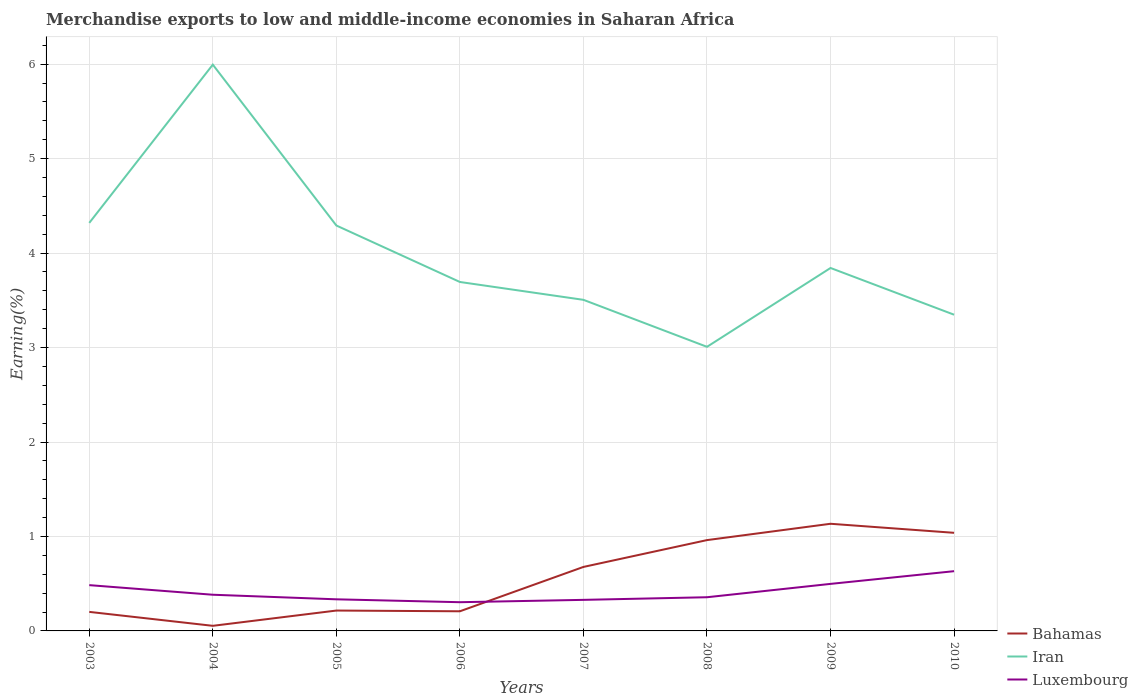How many different coloured lines are there?
Offer a terse response. 3. Does the line corresponding to Iran intersect with the line corresponding to Luxembourg?
Provide a short and direct response. No. Across all years, what is the maximum percentage of amount earned from merchandise exports in Luxembourg?
Make the answer very short. 0.3. What is the total percentage of amount earned from merchandise exports in Iran in the graph?
Your answer should be very brief. 0.5. What is the difference between the highest and the second highest percentage of amount earned from merchandise exports in Iran?
Offer a terse response. 2.99. What is the difference between the highest and the lowest percentage of amount earned from merchandise exports in Bahamas?
Your response must be concise. 4. How many years are there in the graph?
Your answer should be compact. 8. Are the values on the major ticks of Y-axis written in scientific E-notation?
Offer a terse response. No. Does the graph contain any zero values?
Offer a terse response. No. Where does the legend appear in the graph?
Offer a terse response. Bottom right. How many legend labels are there?
Ensure brevity in your answer.  3. What is the title of the graph?
Your answer should be very brief. Merchandise exports to low and middle-income economies in Saharan Africa. What is the label or title of the X-axis?
Your answer should be compact. Years. What is the label or title of the Y-axis?
Offer a terse response. Earning(%). What is the Earning(%) in Bahamas in 2003?
Offer a terse response. 0.2. What is the Earning(%) of Iran in 2003?
Provide a short and direct response. 4.32. What is the Earning(%) of Luxembourg in 2003?
Your response must be concise. 0.48. What is the Earning(%) of Bahamas in 2004?
Your response must be concise. 0.05. What is the Earning(%) in Iran in 2004?
Your answer should be very brief. 6. What is the Earning(%) of Luxembourg in 2004?
Your answer should be compact. 0.38. What is the Earning(%) of Bahamas in 2005?
Provide a short and direct response. 0.22. What is the Earning(%) in Iran in 2005?
Offer a very short reply. 4.29. What is the Earning(%) in Luxembourg in 2005?
Keep it short and to the point. 0.33. What is the Earning(%) of Bahamas in 2006?
Provide a short and direct response. 0.21. What is the Earning(%) of Iran in 2006?
Your answer should be very brief. 3.69. What is the Earning(%) of Luxembourg in 2006?
Keep it short and to the point. 0.3. What is the Earning(%) in Bahamas in 2007?
Your response must be concise. 0.68. What is the Earning(%) of Iran in 2007?
Offer a very short reply. 3.51. What is the Earning(%) in Luxembourg in 2007?
Offer a terse response. 0.33. What is the Earning(%) of Bahamas in 2008?
Offer a terse response. 0.96. What is the Earning(%) of Iran in 2008?
Your answer should be very brief. 3.01. What is the Earning(%) of Luxembourg in 2008?
Your answer should be compact. 0.36. What is the Earning(%) in Bahamas in 2009?
Keep it short and to the point. 1.13. What is the Earning(%) of Iran in 2009?
Your response must be concise. 3.84. What is the Earning(%) of Luxembourg in 2009?
Ensure brevity in your answer.  0.5. What is the Earning(%) of Bahamas in 2010?
Provide a short and direct response. 1.04. What is the Earning(%) of Iran in 2010?
Offer a very short reply. 3.35. What is the Earning(%) of Luxembourg in 2010?
Provide a succinct answer. 0.63. Across all years, what is the maximum Earning(%) of Bahamas?
Keep it short and to the point. 1.13. Across all years, what is the maximum Earning(%) in Iran?
Provide a succinct answer. 6. Across all years, what is the maximum Earning(%) in Luxembourg?
Offer a terse response. 0.63. Across all years, what is the minimum Earning(%) in Bahamas?
Offer a very short reply. 0.05. Across all years, what is the minimum Earning(%) in Iran?
Ensure brevity in your answer.  3.01. Across all years, what is the minimum Earning(%) in Luxembourg?
Offer a very short reply. 0.3. What is the total Earning(%) in Bahamas in the graph?
Your response must be concise. 4.49. What is the total Earning(%) in Iran in the graph?
Your response must be concise. 32. What is the total Earning(%) in Luxembourg in the graph?
Provide a short and direct response. 3.32. What is the difference between the Earning(%) in Bahamas in 2003 and that in 2004?
Your response must be concise. 0.15. What is the difference between the Earning(%) in Iran in 2003 and that in 2004?
Your answer should be very brief. -1.68. What is the difference between the Earning(%) in Luxembourg in 2003 and that in 2004?
Your answer should be compact. 0.1. What is the difference between the Earning(%) of Bahamas in 2003 and that in 2005?
Offer a very short reply. -0.01. What is the difference between the Earning(%) in Iran in 2003 and that in 2005?
Give a very brief answer. 0.03. What is the difference between the Earning(%) in Luxembourg in 2003 and that in 2005?
Ensure brevity in your answer.  0.15. What is the difference between the Earning(%) in Bahamas in 2003 and that in 2006?
Provide a short and direct response. -0.01. What is the difference between the Earning(%) in Iran in 2003 and that in 2006?
Offer a very short reply. 0.63. What is the difference between the Earning(%) of Luxembourg in 2003 and that in 2006?
Make the answer very short. 0.18. What is the difference between the Earning(%) of Bahamas in 2003 and that in 2007?
Offer a very short reply. -0.48. What is the difference between the Earning(%) in Iran in 2003 and that in 2007?
Make the answer very short. 0.81. What is the difference between the Earning(%) of Luxembourg in 2003 and that in 2007?
Ensure brevity in your answer.  0.16. What is the difference between the Earning(%) in Bahamas in 2003 and that in 2008?
Offer a terse response. -0.76. What is the difference between the Earning(%) in Iran in 2003 and that in 2008?
Keep it short and to the point. 1.31. What is the difference between the Earning(%) in Luxembourg in 2003 and that in 2008?
Keep it short and to the point. 0.13. What is the difference between the Earning(%) in Bahamas in 2003 and that in 2009?
Make the answer very short. -0.93. What is the difference between the Earning(%) of Iran in 2003 and that in 2009?
Provide a succinct answer. 0.48. What is the difference between the Earning(%) in Luxembourg in 2003 and that in 2009?
Offer a terse response. -0.01. What is the difference between the Earning(%) of Bahamas in 2003 and that in 2010?
Offer a terse response. -0.84. What is the difference between the Earning(%) of Iran in 2003 and that in 2010?
Give a very brief answer. 0.97. What is the difference between the Earning(%) in Luxembourg in 2003 and that in 2010?
Give a very brief answer. -0.15. What is the difference between the Earning(%) of Bahamas in 2004 and that in 2005?
Your answer should be very brief. -0.16. What is the difference between the Earning(%) in Iran in 2004 and that in 2005?
Offer a terse response. 1.7. What is the difference between the Earning(%) of Luxembourg in 2004 and that in 2005?
Provide a succinct answer. 0.05. What is the difference between the Earning(%) of Bahamas in 2004 and that in 2006?
Make the answer very short. -0.15. What is the difference between the Earning(%) in Iran in 2004 and that in 2006?
Ensure brevity in your answer.  2.3. What is the difference between the Earning(%) in Luxembourg in 2004 and that in 2006?
Keep it short and to the point. 0.08. What is the difference between the Earning(%) of Bahamas in 2004 and that in 2007?
Your response must be concise. -0.62. What is the difference between the Earning(%) in Iran in 2004 and that in 2007?
Provide a short and direct response. 2.49. What is the difference between the Earning(%) of Luxembourg in 2004 and that in 2007?
Your answer should be very brief. 0.05. What is the difference between the Earning(%) in Bahamas in 2004 and that in 2008?
Keep it short and to the point. -0.91. What is the difference between the Earning(%) in Iran in 2004 and that in 2008?
Offer a very short reply. 2.99. What is the difference between the Earning(%) of Luxembourg in 2004 and that in 2008?
Your answer should be compact. 0.03. What is the difference between the Earning(%) in Bahamas in 2004 and that in 2009?
Offer a terse response. -1.08. What is the difference between the Earning(%) in Iran in 2004 and that in 2009?
Your response must be concise. 2.15. What is the difference between the Earning(%) of Luxembourg in 2004 and that in 2009?
Give a very brief answer. -0.11. What is the difference between the Earning(%) in Bahamas in 2004 and that in 2010?
Keep it short and to the point. -0.98. What is the difference between the Earning(%) of Iran in 2004 and that in 2010?
Offer a terse response. 2.65. What is the difference between the Earning(%) of Luxembourg in 2004 and that in 2010?
Your response must be concise. -0.25. What is the difference between the Earning(%) in Bahamas in 2005 and that in 2006?
Ensure brevity in your answer.  0.01. What is the difference between the Earning(%) of Iran in 2005 and that in 2006?
Offer a terse response. 0.6. What is the difference between the Earning(%) in Luxembourg in 2005 and that in 2006?
Keep it short and to the point. 0.03. What is the difference between the Earning(%) of Bahamas in 2005 and that in 2007?
Make the answer very short. -0.46. What is the difference between the Earning(%) of Iran in 2005 and that in 2007?
Make the answer very short. 0.79. What is the difference between the Earning(%) in Luxembourg in 2005 and that in 2007?
Your answer should be compact. 0.01. What is the difference between the Earning(%) in Bahamas in 2005 and that in 2008?
Ensure brevity in your answer.  -0.75. What is the difference between the Earning(%) of Iran in 2005 and that in 2008?
Your response must be concise. 1.28. What is the difference between the Earning(%) of Luxembourg in 2005 and that in 2008?
Give a very brief answer. -0.02. What is the difference between the Earning(%) of Bahamas in 2005 and that in 2009?
Offer a terse response. -0.92. What is the difference between the Earning(%) in Iran in 2005 and that in 2009?
Offer a terse response. 0.45. What is the difference between the Earning(%) of Luxembourg in 2005 and that in 2009?
Offer a very short reply. -0.16. What is the difference between the Earning(%) of Bahamas in 2005 and that in 2010?
Your answer should be compact. -0.82. What is the difference between the Earning(%) in Iran in 2005 and that in 2010?
Offer a very short reply. 0.94. What is the difference between the Earning(%) of Luxembourg in 2005 and that in 2010?
Your answer should be compact. -0.3. What is the difference between the Earning(%) in Bahamas in 2006 and that in 2007?
Provide a short and direct response. -0.47. What is the difference between the Earning(%) in Iran in 2006 and that in 2007?
Provide a succinct answer. 0.19. What is the difference between the Earning(%) of Luxembourg in 2006 and that in 2007?
Your answer should be compact. -0.02. What is the difference between the Earning(%) in Bahamas in 2006 and that in 2008?
Keep it short and to the point. -0.75. What is the difference between the Earning(%) of Iran in 2006 and that in 2008?
Your response must be concise. 0.69. What is the difference between the Earning(%) in Luxembourg in 2006 and that in 2008?
Your response must be concise. -0.05. What is the difference between the Earning(%) in Bahamas in 2006 and that in 2009?
Ensure brevity in your answer.  -0.93. What is the difference between the Earning(%) in Iran in 2006 and that in 2009?
Provide a succinct answer. -0.15. What is the difference between the Earning(%) in Luxembourg in 2006 and that in 2009?
Provide a succinct answer. -0.19. What is the difference between the Earning(%) in Bahamas in 2006 and that in 2010?
Your answer should be very brief. -0.83. What is the difference between the Earning(%) in Iran in 2006 and that in 2010?
Offer a very short reply. 0.35. What is the difference between the Earning(%) in Luxembourg in 2006 and that in 2010?
Give a very brief answer. -0.33. What is the difference between the Earning(%) of Bahamas in 2007 and that in 2008?
Ensure brevity in your answer.  -0.28. What is the difference between the Earning(%) of Iran in 2007 and that in 2008?
Provide a short and direct response. 0.5. What is the difference between the Earning(%) of Luxembourg in 2007 and that in 2008?
Give a very brief answer. -0.03. What is the difference between the Earning(%) of Bahamas in 2007 and that in 2009?
Your answer should be very brief. -0.46. What is the difference between the Earning(%) of Iran in 2007 and that in 2009?
Provide a short and direct response. -0.34. What is the difference between the Earning(%) of Luxembourg in 2007 and that in 2009?
Your answer should be very brief. -0.17. What is the difference between the Earning(%) in Bahamas in 2007 and that in 2010?
Ensure brevity in your answer.  -0.36. What is the difference between the Earning(%) of Iran in 2007 and that in 2010?
Your answer should be compact. 0.16. What is the difference between the Earning(%) of Luxembourg in 2007 and that in 2010?
Make the answer very short. -0.3. What is the difference between the Earning(%) of Bahamas in 2008 and that in 2009?
Provide a succinct answer. -0.17. What is the difference between the Earning(%) of Iran in 2008 and that in 2009?
Give a very brief answer. -0.83. What is the difference between the Earning(%) of Luxembourg in 2008 and that in 2009?
Offer a terse response. -0.14. What is the difference between the Earning(%) in Bahamas in 2008 and that in 2010?
Give a very brief answer. -0.08. What is the difference between the Earning(%) in Iran in 2008 and that in 2010?
Offer a very short reply. -0.34. What is the difference between the Earning(%) of Luxembourg in 2008 and that in 2010?
Offer a terse response. -0.28. What is the difference between the Earning(%) of Bahamas in 2009 and that in 2010?
Give a very brief answer. 0.1. What is the difference between the Earning(%) in Iran in 2009 and that in 2010?
Offer a terse response. 0.49. What is the difference between the Earning(%) in Luxembourg in 2009 and that in 2010?
Offer a terse response. -0.13. What is the difference between the Earning(%) of Bahamas in 2003 and the Earning(%) of Iran in 2004?
Give a very brief answer. -5.79. What is the difference between the Earning(%) of Bahamas in 2003 and the Earning(%) of Luxembourg in 2004?
Offer a very short reply. -0.18. What is the difference between the Earning(%) in Iran in 2003 and the Earning(%) in Luxembourg in 2004?
Keep it short and to the point. 3.94. What is the difference between the Earning(%) in Bahamas in 2003 and the Earning(%) in Iran in 2005?
Your answer should be very brief. -4.09. What is the difference between the Earning(%) of Bahamas in 2003 and the Earning(%) of Luxembourg in 2005?
Your answer should be compact. -0.13. What is the difference between the Earning(%) in Iran in 2003 and the Earning(%) in Luxembourg in 2005?
Your answer should be very brief. 3.99. What is the difference between the Earning(%) in Bahamas in 2003 and the Earning(%) in Iran in 2006?
Ensure brevity in your answer.  -3.49. What is the difference between the Earning(%) in Bahamas in 2003 and the Earning(%) in Luxembourg in 2006?
Offer a terse response. -0.1. What is the difference between the Earning(%) in Iran in 2003 and the Earning(%) in Luxembourg in 2006?
Ensure brevity in your answer.  4.02. What is the difference between the Earning(%) of Bahamas in 2003 and the Earning(%) of Iran in 2007?
Your answer should be compact. -3.3. What is the difference between the Earning(%) in Bahamas in 2003 and the Earning(%) in Luxembourg in 2007?
Ensure brevity in your answer.  -0.13. What is the difference between the Earning(%) of Iran in 2003 and the Earning(%) of Luxembourg in 2007?
Keep it short and to the point. 3.99. What is the difference between the Earning(%) of Bahamas in 2003 and the Earning(%) of Iran in 2008?
Provide a succinct answer. -2.81. What is the difference between the Earning(%) in Bahamas in 2003 and the Earning(%) in Luxembourg in 2008?
Offer a terse response. -0.16. What is the difference between the Earning(%) in Iran in 2003 and the Earning(%) in Luxembourg in 2008?
Ensure brevity in your answer.  3.96. What is the difference between the Earning(%) of Bahamas in 2003 and the Earning(%) of Iran in 2009?
Provide a succinct answer. -3.64. What is the difference between the Earning(%) in Bahamas in 2003 and the Earning(%) in Luxembourg in 2009?
Your answer should be compact. -0.3. What is the difference between the Earning(%) of Iran in 2003 and the Earning(%) of Luxembourg in 2009?
Your response must be concise. 3.82. What is the difference between the Earning(%) of Bahamas in 2003 and the Earning(%) of Iran in 2010?
Keep it short and to the point. -3.15. What is the difference between the Earning(%) of Bahamas in 2003 and the Earning(%) of Luxembourg in 2010?
Provide a short and direct response. -0.43. What is the difference between the Earning(%) of Iran in 2003 and the Earning(%) of Luxembourg in 2010?
Keep it short and to the point. 3.69. What is the difference between the Earning(%) in Bahamas in 2004 and the Earning(%) in Iran in 2005?
Your answer should be very brief. -4.24. What is the difference between the Earning(%) in Bahamas in 2004 and the Earning(%) in Luxembourg in 2005?
Keep it short and to the point. -0.28. What is the difference between the Earning(%) of Iran in 2004 and the Earning(%) of Luxembourg in 2005?
Make the answer very short. 5.66. What is the difference between the Earning(%) in Bahamas in 2004 and the Earning(%) in Iran in 2006?
Your response must be concise. -3.64. What is the difference between the Earning(%) of Bahamas in 2004 and the Earning(%) of Luxembourg in 2006?
Offer a very short reply. -0.25. What is the difference between the Earning(%) of Iran in 2004 and the Earning(%) of Luxembourg in 2006?
Keep it short and to the point. 5.69. What is the difference between the Earning(%) of Bahamas in 2004 and the Earning(%) of Iran in 2007?
Keep it short and to the point. -3.45. What is the difference between the Earning(%) of Bahamas in 2004 and the Earning(%) of Luxembourg in 2007?
Make the answer very short. -0.27. What is the difference between the Earning(%) in Iran in 2004 and the Earning(%) in Luxembourg in 2007?
Offer a terse response. 5.67. What is the difference between the Earning(%) of Bahamas in 2004 and the Earning(%) of Iran in 2008?
Keep it short and to the point. -2.95. What is the difference between the Earning(%) of Bahamas in 2004 and the Earning(%) of Luxembourg in 2008?
Make the answer very short. -0.3. What is the difference between the Earning(%) of Iran in 2004 and the Earning(%) of Luxembourg in 2008?
Provide a short and direct response. 5.64. What is the difference between the Earning(%) in Bahamas in 2004 and the Earning(%) in Iran in 2009?
Make the answer very short. -3.79. What is the difference between the Earning(%) in Bahamas in 2004 and the Earning(%) in Luxembourg in 2009?
Ensure brevity in your answer.  -0.44. What is the difference between the Earning(%) of Iran in 2004 and the Earning(%) of Luxembourg in 2009?
Give a very brief answer. 5.5. What is the difference between the Earning(%) in Bahamas in 2004 and the Earning(%) in Iran in 2010?
Your answer should be compact. -3.29. What is the difference between the Earning(%) of Bahamas in 2004 and the Earning(%) of Luxembourg in 2010?
Your response must be concise. -0.58. What is the difference between the Earning(%) in Iran in 2004 and the Earning(%) in Luxembourg in 2010?
Offer a terse response. 5.36. What is the difference between the Earning(%) in Bahamas in 2005 and the Earning(%) in Iran in 2006?
Your answer should be very brief. -3.48. What is the difference between the Earning(%) in Bahamas in 2005 and the Earning(%) in Luxembourg in 2006?
Offer a terse response. -0.09. What is the difference between the Earning(%) of Iran in 2005 and the Earning(%) of Luxembourg in 2006?
Offer a very short reply. 3.99. What is the difference between the Earning(%) of Bahamas in 2005 and the Earning(%) of Iran in 2007?
Provide a short and direct response. -3.29. What is the difference between the Earning(%) of Bahamas in 2005 and the Earning(%) of Luxembourg in 2007?
Make the answer very short. -0.11. What is the difference between the Earning(%) of Iran in 2005 and the Earning(%) of Luxembourg in 2007?
Offer a terse response. 3.96. What is the difference between the Earning(%) of Bahamas in 2005 and the Earning(%) of Iran in 2008?
Keep it short and to the point. -2.79. What is the difference between the Earning(%) of Bahamas in 2005 and the Earning(%) of Luxembourg in 2008?
Make the answer very short. -0.14. What is the difference between the Earning(%) in Iran in 2005 and the Earning(%) in Luxembourg in 2008?
Your answer should be very brief. 3.94. What is the difference between the Earning(%) of Bahamas in 2005 and the Earning(%) of Iran in 2009?
Make the answer very short. -3.63. What is the difference between the Earning(%) in Bahamas in 2005 and the Earning(%) in Luxembourg in 2009?
Offer a terse response. -0.28. What is the difference between the Earning(%) in Iran in 2005 and the Earning(%) in Luxembourg in 2009?
Your response must be concise. 3.79. What is the difference between the Earning(%) in Bahamas in 2005 and the Earning(%) in Iran in 2010?
Provide a succinct answer. -3.13. What is the difference between the Earning(%) in Bahamas in 2005 and the Earning(%) in Luxembourg in 2010?
Make the answer very short. -0.42. What is the difference between the Earning(%) of Iran in 2005 and the Earning(%) of Luxembourg in 2010?
Ensure brevity in your answer.  3.66. What is the difference between the Earning(%) in Bahamas in 2006 and the Earning(%) in Iran in 2007?
Your response must be concise. -3.3. What is the difference between the Earning(%) of Bahamas in 2006 and the Earning(%) of Luxembourg in 2007?
Your response must be concise. -0.12. What is the difference between the Earning(%) in Iran in 2006 and the Earning(%) in Luxembourg in 2007?
Provide a short and direct response. 3.37. What is the difference between the Earning(%) in Bahamas in 2006 and the Earning(%) in Iran in 2008?
Ensure brevity in your answer.  -2.8. What is the difference between the Earning(%) in Bahamas in 2006 and the Earning(%) in Luxembourg in 2008?
Ensure brevity in your answer.  -0.15. What is the difference between the Earning(%) in Iran in 2006 and the Earning(%) in Luxembourg in 2008?
Ensure brevity in your answer.  3.34. What is the difference between the Earning(%) of Bahamas in 2006 and the Earning(%) of Iran in 2009?
Offer a terse response. -3.63. What is the difference between the Earning(%) of Bahamas in 2006 and the Earning(%) of Luxembourg in 2009?
Make the answer very short. -0.29. What is the difference between the Earning(%) of Iran in 2006 and the Earning(%) of Luxembourg in 2009?
Your answer should be very brief. 3.2. What is the difference between the Earning(%) of Bahamas in 2006 and the Earning(%) of Iran in 2010?
Offer a very short reply. -3.14. What is the difference between the Earning(%) in Bahamas in 2006 and the Earning(%) in Luxembourg in 2010?
Keep it short and to the point. -0.42. What is the difference between the Earning(%) of Iran in 2006 and the Earning(%) of Luxembourg in 2010?
Keep it short and to the point. 3.06. What is the difference between the Earning(%) in Bahamas in 2007 and the Earning(%) in Iran in 2008?
Give a very brief answer. -2.33. What is the difference between the Earning(%) in Bahamas in 2007 and the Earning(%) in Luxembourg in 2008?
Provide a succinct answer. 0.32. What is the difference between the Earning(%) in Iran in 2007 and the Earning(%) in Luxembourg in 2008?
Provide a succinct answer. 3.15. What is the difference between the Earning(%) of Bahamas in 2007 and the Earning(%) of Iran in 2009?
Your answer should be compact. -3.16. What is the difference between the Earning(%) in Bahamas in 2007 and the Earning(%) in Luxembourg in 2009?
Offer a very short reply. 0.18. What is the difference between the Earning(%) of Iran in 2007 and the Earning(%) of Luxembourg in 2009?
Offer a very short reply. 3.01. What is the difference between the Earning(%) of Bahamas in 2007 and the Earning(%) of Iran in 2010?
Your response must be concise. -2.67. What is the difference between the Earning(%) in Bahamas in 2007 and the Earning(%) in Luxembourg in 2010?
Make the answer very short. 0.05. What is the difference between the Earning(%) of Iran in 2007 and the Earning(%) of Luxembourg in 2010?
Your response must be concise. 2.87. What is the difference between the Earning(%) of Bahamas in 2008 and the Earning(%) of Iran in 2009?
Your answer should be compact. -2.88. What is the difference between the Earning(%) in Bahamas in 2008 and the Earning(%) in Luxembourg in 2009?
Your answer should be compact. 0.46. What is the difference between the Earning(%) of Iran in 2008 and the Earning(%) of Luxembourg in 2009?
Your answer should be very brief. 2.51. What is the difference between the Earning(%) in Bahamas in 2008 and the Earning(%) in Iran in 2010?
Make the answer very short. -2.39. What is the difference between the Earning(%) in Bahamas in 2008 and the Earning(%) in Luxembourg in 2010?
Make the answer very short. 0.33. What is the difference between the Earning(%) in Iran in 2008 and the Earning(%) in Luxembourg in 2010?
Give a very brief answer. 2.38. What is the difference between the Earning(%) in Bahamas in 2009 and the Earning(%) in Iran in 2010?
Give a very brief answer. -2.21. What is the difference between the Earning(%) of Bahamas in 2009 and the Earning(%) of Luxembourg in 2010?
Your response must be concise. 0.5. What is the difference between the Earning(%) of Iran in 2009 and the Earning(%) of Luxembourg in 2010?
Your response must be concise. 3.21. What is the average Earning(%) in Bahamas per year?
Offer a very short reply. 0.56. What is the average Earning(%) in Iran per year?
Give a very brief answer. 4. What is the average Earning(%) of Luxembourg per year?
Your response must be concise. 0.42. In the year 2003, what is the difference between the Earning(%) in Bahamas and Earning(%) in Iran?
Ensure brevity in your answer.  -4.12. In the year 2003, what is the difference between the Earning(%) of Bahamas and Earning(%) of Luxembourg?
Offer a terse response. -0.28. In the year 2003, what is the difference between the Earning(%) of Iran and Earning(%) of Luxembourg?
Keep it short and to the point. 3.84. In the year 2004, what is the difference between the Earning(%) of Bahamas and Earning(%) of Iran?
Make the answer very short. -5.94. In the year 2004, what is the difference between the Earning(%) in Bahamas and Earning(%) in Luxembourg?
Your answer should be very brief. -0.33. In the year 2004, what is the difference between the Earning(%) of Iran and Earning(%) of Luxembourg?
Your answer should be very brief. 5.61. In the year 2005, what is the difference between the Earning(%) of Bahamas and Earning(%) of Iran?
Your response must be concise. -4.08. In the year 2005, what is the difference between the Earning(%) of Bahamas and Earning(%) of Luxembourg?
Offer a terse response. -0.12. In the year 2005, what is the difference between the Earning(%) in Iran and Earning(%) in Luxembourg?
Make the answer very short. 3.96. In the year 2006, what is the difference between the Earning(%) in Bahamas and Earning(%) in Iran?
Make the answer very short. -3.49. In the year 2006, what is the difference between the Earning(%) of Bahamas and Earning(%) of Luxembourg?
Your answer should be very brief. -0.1. In the year 2006, what is the difference between the Earning(%) of Iran and Earning(%) of Luxembourg?
Make the answer very short. 3.39. In the year 2007, what is the difference between the Earning(%) of Bahamas and Earning(%) of Iran?
Keep it short and to the point. -2.83. In the year 2007, what is the difference between the Earning(%) in Bahamas and Earning(%) in Luxembourg?
Your answer should be compact. 0.35. In the year 2007, what is the difference between the Earning(%) in Iran and Earning(%) in Luxembourg?
Offer a very short reply. 3.18. In the year 2008, what is the difference between the Earning(%) of Bahamas and Earning(%) of Iran?
Give a very brief answer. -2.05. In the year 2008, what is the difference between the Earning(%) of Bahamas and Earning(%) of Luxembourg?
Your response must be concise. 0.6. In the year 2008, what is the difference between the Earning(%) in Iran and Earning(%) in Luxembourg?
Your answer should be compact. 2.65. In the year 2009, what is the difference between the Earning(%) in Bahamas and Earning(%) in Iran?
Offer a very short reply. -2.71. In the year 2009, what is the difference between the Earning(%) of Bahamas and Earning(%) of Luxembourg?
Give a very brief answer. 0.64. In the year 2009, what is the difference between the Earning(%) in Iran and Earning(%) in Luxembourg?
Provide a succinct answer. 3.34. In the year 2010, what is the difference between the Earning(%) in Bahamas and Earning(%) in Iran?
Your answer should be compact. -2.31. In the year 2010, what is the difference between the Earning(%) of Bahamas and Earning(%) of Luxembourg?
Keep it short and to the point. 0.41. In the year 2010, what is the difference between the Earning(%) in Iran and Earning(%) in Luxembourg?
Your response must be concise. 2.72. What is the ratio of the Earning(%) of Bahamas in 2003 to that in 2004?
Your answer should be compact. 3.73. What is the ratio of the Earning(%) in Iran in 2003 to that in 2004?
Your answer should be very brief. 0.72. What is the ratio of the Earning(%) of Luxembourg in 2003 to that in 2004?
Give a very brief answer. 1.27. What is the ratio of the Earning(%) of Bahamas in 2003 to that in 2005?
Keep it short and to the point. 0.93. What is the ratio of the Earning(%) in Iran in 2003 to that in 2005?
Offer a very short reply. 1.01. What is the ratio of the Earning(%) of Luxembourg in 2003 to that in 2005?
Your answer should be very brief. 1.45. What is the ratio of the Earning(%) in Bahamas in 2003 to that in 2006?
Your answer should be compact. 0.97. What is the ratio of the Earning(%) of Iran in 2003 to that in 2006?
Offer a terse response. 1.17. What is the ratio of the Earning(%) in Luxembourg in 2003 to that in 2006?
Offer a very short reply. 1.59. What is the ratio of the Earning(%) in Bahamas in 2003 to that in 2007?
Your answer should be compact. 0.3. What is the ratio of the Earning(%) in Iran in 2003 to that in 2007?
Offer a terse response. 1.23. What is the ratio of the Earning(%) in Luxembourg in 2003 to that in 2007?
Ensure brevity in your answer.  1.47. What is the ratio of the Earning(%) of Bahamas in 2003 to that in 2008?
Offer a very short reply. 0.21. What is the ratio of the Earning(%) in Iran in 2003 to that in 2008?
Offer a very short reply. 1.44. What is the ratio of the Earning(%) in Luxembourg in 2003 to that in 2008?
Provide a succinct answer. 1.36. What is the ratio of the Earning(%) of Bahamas in 2003 to that in 2009?
Make the answer very short. 0.18. What is the ratio of the Earning(%) of Iran in 2003 to that in 2009?
Offer a very short reply. 1.12. What is the ratio of the Earning(%) of Luxembourg in 2003 to that in 2009?
Offer a very short reply. 0.97. What is the ratio of the Earning(%) of Bahamas in 2003 to that in 2010?
Your response must be concise. 0.19. What is the ratio of the Earning(%) of Iran in 2003 to that in 2010?
Offer a very short reply. 1.29. What is the ratio of the Earning(%) of Luxembourg in 2003 to that in 2010?
Give a very brief answer. 0.77. What is the ratio of the Earning(%) in Bahamas in 2004 to that in 2005?
Your response must be concise. 0.25. What is the ratio of the Earning(%) of Iran in 2004 to that in 2005?
Your answer should be very brief. 1.4. What is the ratio of the Earning(%) in Luxembourg in 2004 to that in 2005?
Provide a short and direct response. 1.14. What is the ratio of the Earning(%) in Bahamas in 2004 to that in 2006?
Offer a very short reply. 0.26. What is the ratio of the Earning(%) of Iran in 2004 to that in 2006?
Provide a short and direct response. 1.62. What is the ratio of the Earning(%) in Luxembourg in 2004 to that in 2006?
Your answer should be very brief. 1.26. What is the ratio of the Earning(%) of Bahamas in 2004 to that in 2007?
Offer a terse response. 0.08. What is the ratio of the Earning(%) in Iran in 2004 to that in 2007?
Your answer should be compact. 1.71. What is the ratio of the Earning(%) in Luxembourg in 2004 to that in 2007?
Offer a very short reply. 1.16. What is the ratio of the Earning(%) of Bahamas in 2004 to that in 2008?
Ensure brevity in your answer.  0.06. What is the ratio of the Earning(%) in Iran in 2004 to that in 2008?
Your response must be concise. 1.99. What is the ratio of the Earning(%) in Luxembourg in 2004 to that in 2008?
Offer a terse response. 1.07. What is the ratio of the Earning(%) in Bahamas in 2004 to that in 2009?
Your response must be concise. 0.05. What is the ratio of the Earning(%) in Iran in 2004 to that in 2009?
Offer a terse response. 1.56. What is the ratio of the Earning(%) of Luxembourg in 2004 to that in 2009?
Keep it short and to the point. 0.77. What is the ratio of the Earning(%) in Bahamas in 2004 to that in 2010?
Give a very brief answer. 0.05. What is the ratio of the Earning(%) of Iran in 2004 to that in 2010?
Your answer should be compact. 1.79. What is the ratio of the Earning(%) in Luxembourg in 2004 to that in 2010?
Your response must be concise. 0.61. What is the ratio of the Earning(%) in Bahamas in 2005 to that in 2006?
Your answer should be very brief. 1.04. What is the ratio of the Earning(%) in Iran in 2005 to that in 2006?
Provide a succinct answer. 1.16. What is the ratio of the Earning(%) in Luxembourg in 2005 to that in 2006?
Make the answer very short. 1.1. What is the ratio of the Earning(%) of Bahamas in 2005 to that in 2007?
Make the answer very short. 0.32. What is the ratio of the Earning(%) of Iran in 2005 to that in 2007?
Offer a terse response. 1.22. What is the ratio of the Earning(%) of Luxembourg in 2005 to that in 2007?
Offer a terse response. 1.02. What is the ratio of the Earning(%) in Bahamas in 2005 to that in 2008?
Offer a terse response. 0.22. What is the ratio of the Earning(%) of Iran in 2005 to that in 2008?
Offer a terse response. 1.43. What is the ratio of the Earning(%) of Luxembourg in 2005 to that in 2008?
Offer a very short reply. 0.94. What is the ratio of the Earning(%) in Bahamas in 2005 to that in 2009?
Keep it short and to the point. 0.19. What is the ratio of the Earning(%) of Iran in 2005 to that in 2009?
Offer a terse response. 1.12. What is the ratio of the Earning(%) in Luxembourg in 2005 to that in 2009?
Keep it short and to the point. 0.67. What is the ratio of the Earning(%) of Bahamas in 2005 to that in 2010?
Ensure brevity in your answer.  0.21. What is the ratio of the Earning(%) in Iran in 2005 to that in 2010?
Your response must be concise. 1.28. What is the ratio of the Earning(%) of Luxembourg in 2005 to that in 2010?
Provide a short and direct response. 0.53. What is the ratio of the Earning(%) in Bahamas in 2006 to that in 2007?
Offer a very short reply. 0.31. What is the ratio of the Earning(%) in Iran in 2006 to that in 2007?
Provide a succinct answer. 1.05. What is the ratio of the Earning(%) of Luxembourg in 2006 to that in 2007?
Offer a very short reply. 0.92. What is the ratio of the Earning(%) of Bahamas in 2006 to that in 2008?
Make the answer very short. 0.22. What is the ratio of the Earning(%) of Iran in 2006 to that in 2008?
Give a very brief answer. 1.23. What is the ratio of the Earning(%) of Luxembourg in 2006 to that in 2008?
Ensure brevity in your answer.  0.85. What is the ratio of the Earning(%) of Bahamas in 2006 to that in 2009?
Your answer should be compact. 0.18. What is the ratio of the Earning(%) in Iran in 2006 to that in 2009?
Give a very brief answer. 0.96. What is the ratio of the Earning(%) in Luxembourg in 2006 to that in 2009?
Provide a short and direct response. 0.61. What is the ratio of the Earning(%) of Bahamas in 2006 to that in 2010?
Give a very brief answer. 0.2. What is the ratio of the Earning(%) of Iran in 2006 to that in 2010?
Keep it short and to the point. 1.1. What is the ratio of the Earning(%) of Luxembourg in 2006 to that in 2010?
Offer a terse response. 0.48. What is the ratio of the Earning(%) in Bahamas in 2007 to that in 2008?
Your answer should be compact. 0.7. What is the ratio of the Earning(%) of Iran in 2007 to that in 2008?
Keep it short and to the point. 1.17. What is the ratio of the Earning(%) of Luxembourg in 2007 to that in 2008?
Your answer should be very brief. 0.92. What is the ratio of the Earning(%) of Bahamas in 2007 to that in 2009?
Keep it short and to the point. 0.6. What is the ratio of the Earning(%) of Iran in 2007 to that in 2009?
Offer a terse response. 0.91. What is the ratio of the Earning(%) in Luxembourg in 2007 to that in 2009?
Your response must be concise. 0.66. What is the ratio of the Earning(%) of Bahamas in 2007 to that in 2010?
Your answer should be compact. 0.65. What is the ratio of the Earning(%) in Iran in 2007 to that in 2010?
Give a very brief answer. 1.05. What is the ratio of the Earning(%) in Luxembourg in 2007 to that in 2010?
Keep it short and to the point. 0.52. What is the ratio of the Earning(%) in Bahamas in 2008 to that in 2009?
Your answer should be very brief. 0.85. What is the ratio of the Earning(%) in Iran in 2008 to that in 2009?
Provide a succinct answer. 0.78. What is the ratio of the Earning(%) of Luxembourg in 2008 to that in 2009?
Provide a succinct answer. 0.72. What is the ratio of the Earning(%) of Bahamas in 2008 to that in 2010?
Provide a short and direct response. 0.93. What is the ratio of the Earning(%) of Iran in 2008 to that in 2010?
Offer a terse response. 0.9. What is the ratio of the Earning(%) of Luxembourg in 2008 to that in 2010?
Make the answer very short. 0.56. What is the ratio of the Earning(%) in Bahamas in 2009 to that in 2010?
Provide a short and direct response. 1.09. What is the ratio of the Earning(%) in Iran in 2009 to that in 2010?
Your response must be concise. 1.15. What is the ratio of the Earning(%) in Luxembourg in 2009 to that in 2010?
Your answer should be compact. 0.79. What is the difference between the highest and the second highest Earning(%) of Bahamas?
Keep it short and to the point. 0.1. What is the difference between the highest and the second highest Earning(%) of Iran?
Provide a succinct answer. 1.68. What is the difference between the highest and the second highest Earning(%) of Luxembourg?
Your answer should be compact. 0.13. What is the difference between the highest and the lowest Earning(%) of Bahamas?
Your answer should be very brief. 1.08. What is the difference between the highest and the lowest Earning(%) in Iran?
Ensure brevity in your answer.  2.99. What is the difference between the highest and the lowest Earning(%) in Luxembourg?
Offer a very short reply. 0.33. 